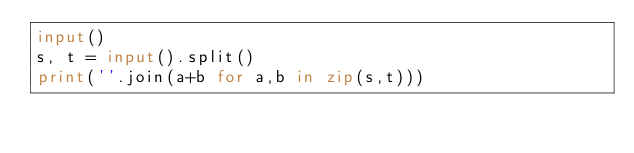<code> <loc_0><loc_0><loc_500><loc_500><_Python_>input()
s, t = input().split()
print(''.join(a+b for a,b in zip(s,t)))</code> 